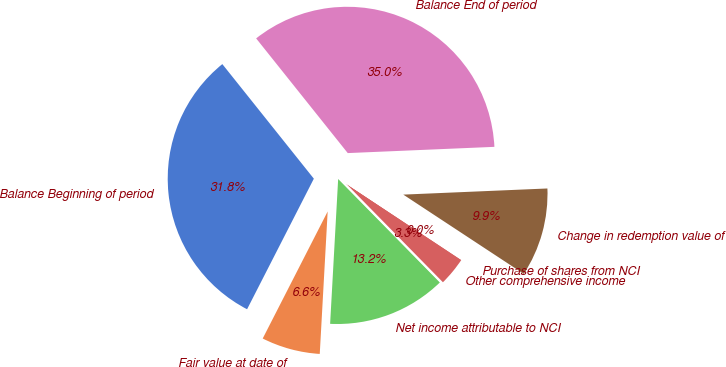Convert chart to OTSL. <chart><loc_0><loc_0><loc_500><loc_500><pie_chart><fcel>Balance Beginning of period<fcel>Fair value at date of<fcel>Net income attributable to NCI<fcel>Other comprehensive income<fcel>Purchase of shares from NCI<fcel>Change in redemption value of<fcel>Balance End of period<nl><fcel>31.75%<fcel>6.64%<fcel>13.24%<fcel>3.34%<fcel>0.04%<fcel>9.94%<fcel>35.05%<nl></chart> 